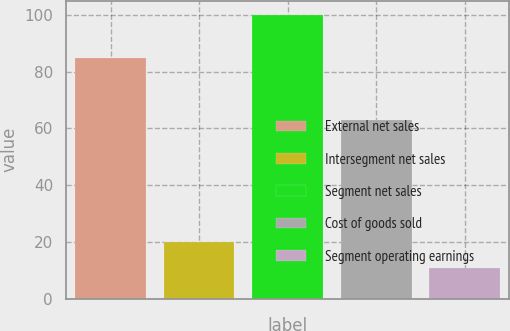Convert chart to OTSL. <chart><loc_0><loc_0><loc_500><loc_500><bar_chart><fcel>External net sales<fcel>Intersegment net sales<fcel>Segment net sales<fcel>Cost of goods sold<fcel>Segment operating earnings<nl><fcel>84.9<fcel>19.9<fcel>100<fcel>63.1<fcel>11<nl></chart> 